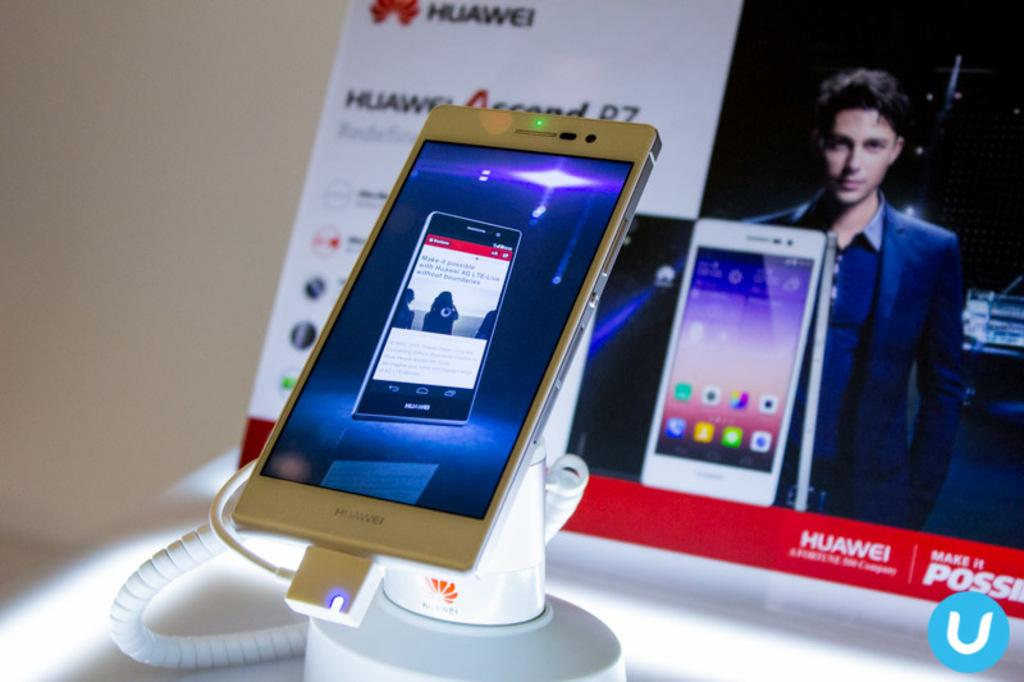<image>
Describe the image concisely. A white Huawei phone is charging and on display. 